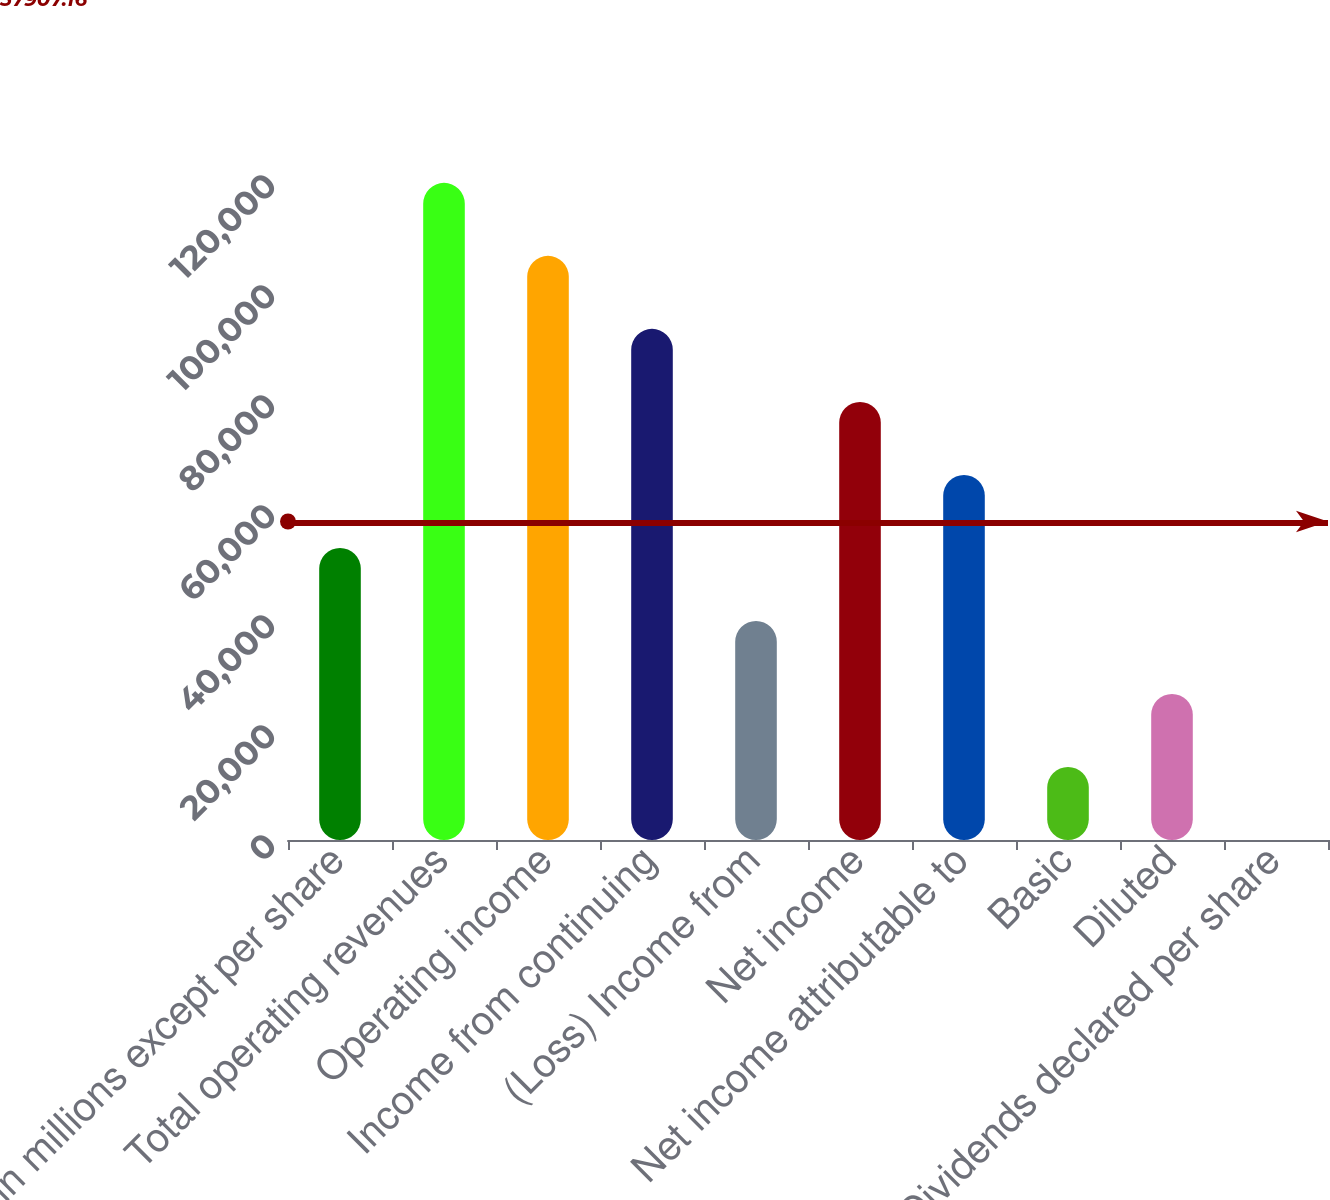<chart> <loc_0><loc_0><loc_500><loc_500><bar_chart><fcel>(in millions except per share<fcel>Total operating revenues<fcel>Operating income<fcel>Income from continuing<fcel>(Loss) Income from<fcel>Net income<fcel>Net income attributable to<fcel>Basic<fcel>Diluted<fcel>Dividends declared per share<nl><fcel>53106.4<fcel>119485<fcel>106209<fcel>92933.7<fcel>39830.6<fcel>79657.9<fcel>66382.2<fcel>13279.1<fcel>26554.9<fcel>3.36<nl></chart> 